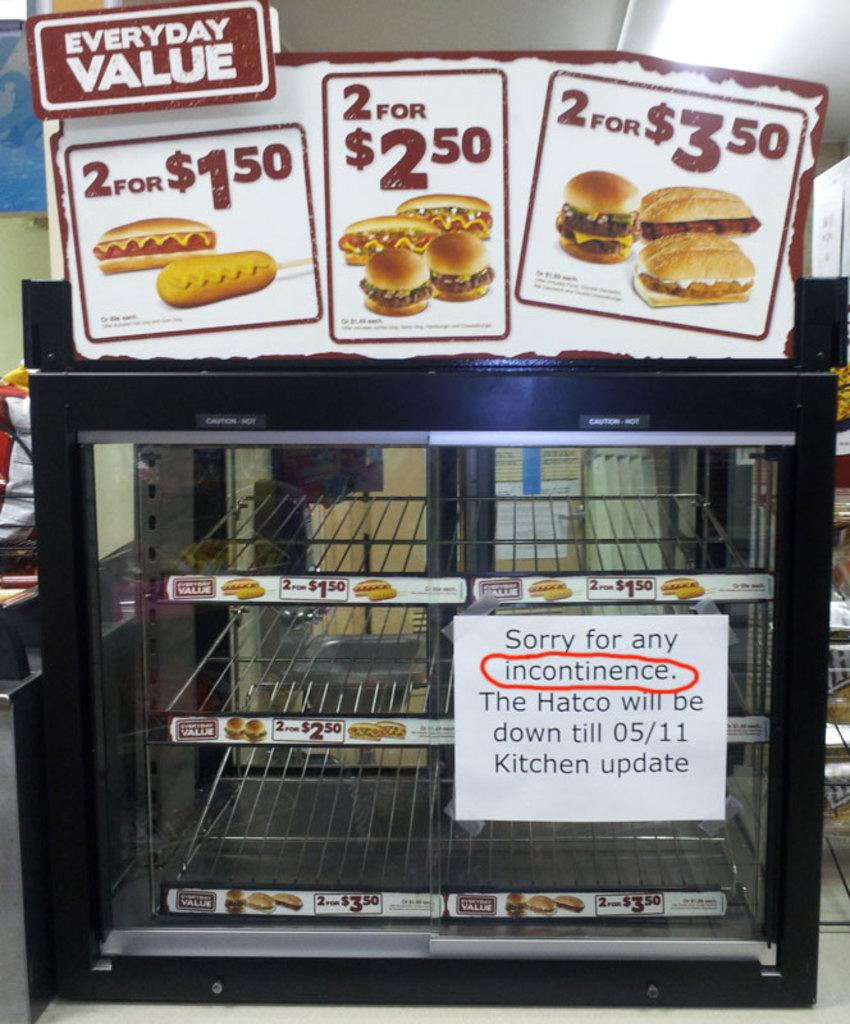<image>
Render a clear and concise summary of the photo. A sign with the word inconvenience misspelled as incontinence is posted on a display case. 